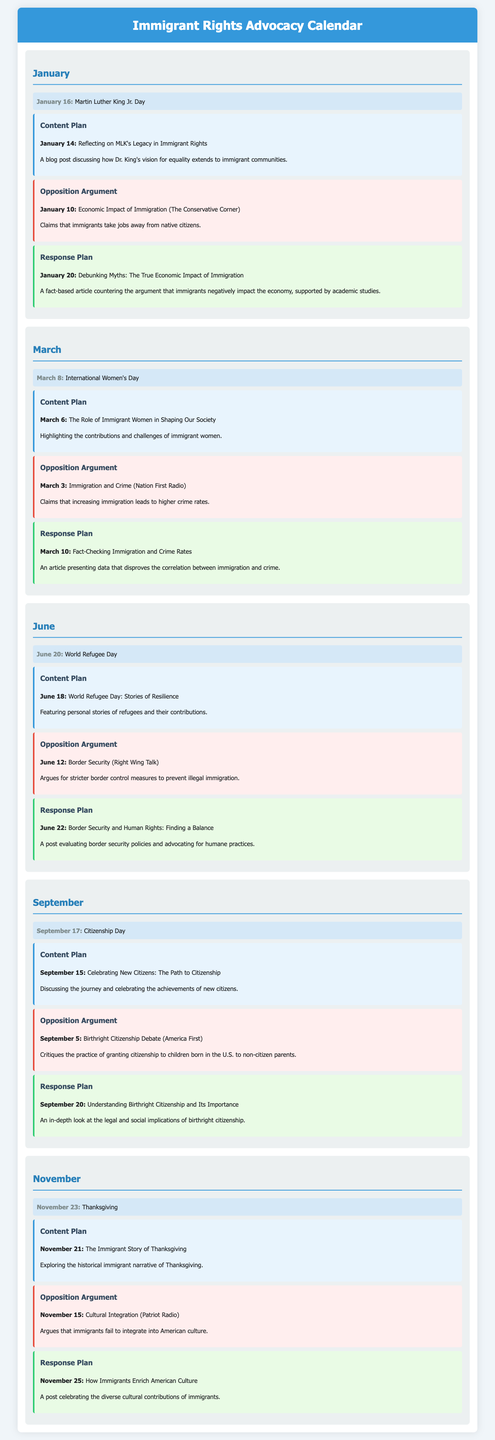what is the date for Martin Luther King Jr. Day? The document specifies that Martin Luther King Jr. Day is on January 16.
Answer: January 16 what is the title of the blog post planned for March 6? The blog post planned for March 6 is titled "The Role of Immigrant Women in Shaping Our Society."
Answer: The Role of Immigrant Women in Shaping Our Society which event is celebrated on June 20? The document states that June 20 is celebrated as World Refugee Day.
Answer: World Refugee Day what is the opposition argument made on March 3? The opposition argument on March 3 claims that increasing immigration leads to higher crime rates.
Answer: Immigration and Crime how many days before Citizenship Day is the response article planned? The response article is planned for September 20, which is two days after the content plan on September 15 and just two days before Citizenship Day on September 17.
Answer: Two days what does the blog post planned for November 21 focus on? The document indicates that the blog post planned for November 21 focuses on the historical immigrant narrative of Thanksgiving.
Answer: The historical immigrant narrative of Thanksgiving which organization is mentioned in opposition to immigration claims in June? The document mentions Right Wing Talk as the organization arguing for stricter border control measures.
Answer: Right Wing Talk what is the purpose of the response planned for June 22? The response planned for June 22 evaluates border security policies and advocates for humane practices.
Answer: Evaluating border security policies and advocating for humane practices 